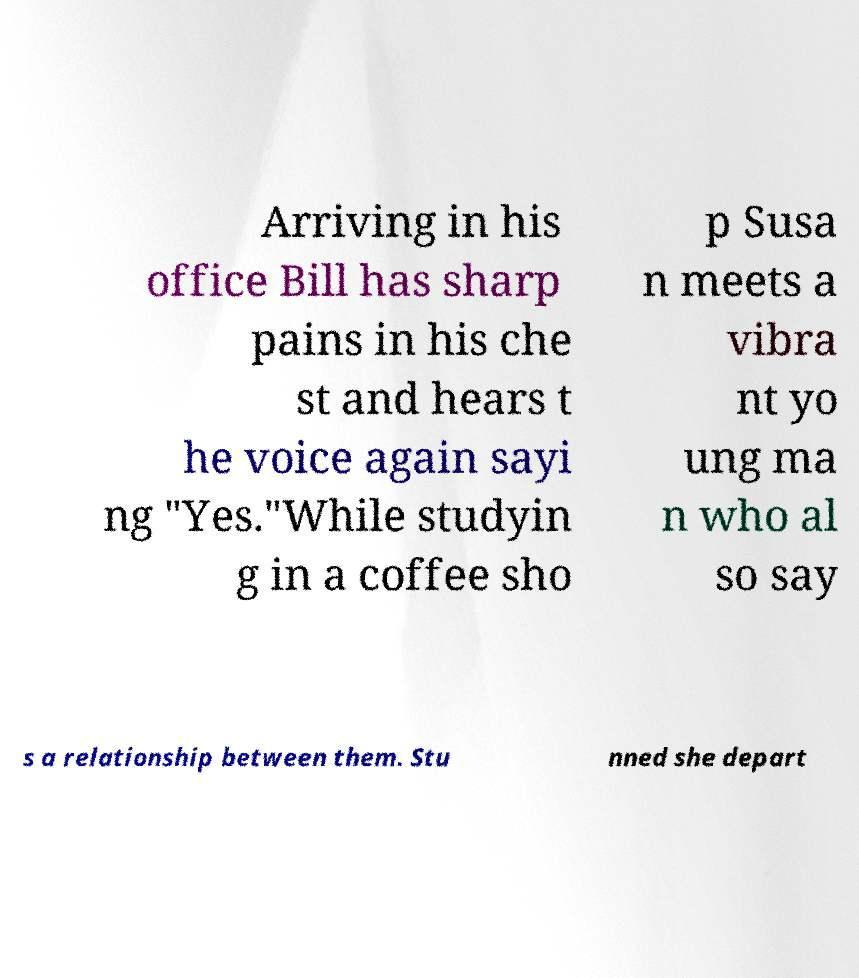Can you accurately transcribe the text from the provided image for me? Arriving in his office Bill has sharp pains in his che st and hears t he voice again sayi ng "Yes."While studyin g in a coffee sho p Susa n meets a vibra nt yo ung ma n who al so say s a relationship between them. Stu nned she depart 